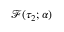<formula> <loc_0><loc_0><loc_500><loc_500>\mathcal { F } ( \tau _ { 2 } ; \alpha )</formula> 